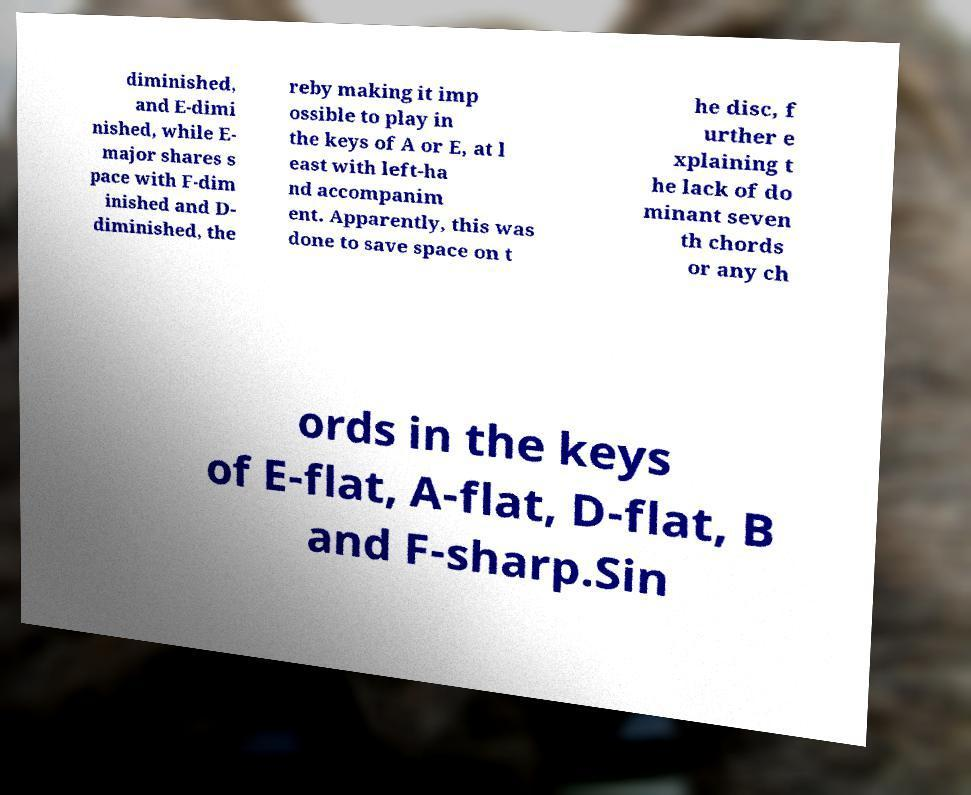I need the written content from this picture converted into text. Can you do that? diminished, and E-dimi nished, while E- major shares s pace with F-dim inished and D- diminished, the reby making it imp ossible to play in the keys of A or E, at l east with left-ha nd accompanim ent. Apparently, this was done to save space on t he disc, f urther e xplaining t he lack of do minant seven th chords or any ch ords in the keys of E-flat, A-flat, D-flat, B and F-sharp.Sin 